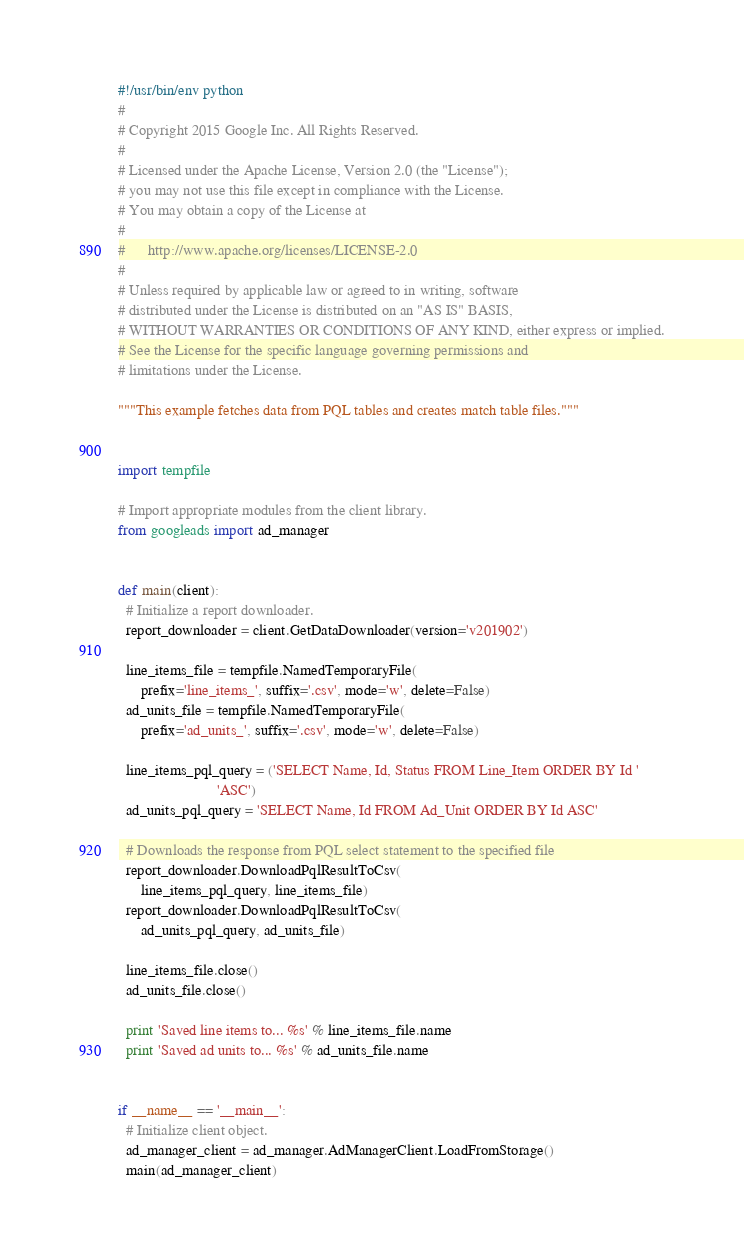<code> <loc_0><loc_0><loc_500><loc_500><_Python_>#!/usr/bin/env python
#
# Copyright 2015 Google Inc. All Rights Reserved.
#
# Licensed under the Apache License, Version 2.0 (the "License");
# you may not use this file except in compliance with the License.
# You may obtain a copy of the License at
#
#      http://www.apache.org/licenses/LICENSE-2.0
#
# Unless required by applicable law or agreed to in writing, software
# distributed under the License is distributed on an "AS IS" BASIS,
# WITHOUT WARRANTIES OR CONDITIONS OF ANY KIND, either express or implied.
# See the License for the specific language governing permissions and
# limitations under the License.

"""This example fetches data from PQL tables and creates match table files."""


import tempfile

# Import appropriate modules from the client library.
from googleads import ad_manager


def main(client):
  # Initialize a report downloader.
  report_downloader = client.GetDataDownloader(version='v201902')

  line_items_file = tempfile.NamedTemporaryFile(
      prefix='line_items_', suffix='.csv', mode='w', delete=False)
  ad_units_file = tempfile.NamedTemporaryFile(
      prefix='ad_units_', suffix='.csv', mode='w', delete=False)

  line_items_pql_query = ('SELECT Name, Id, Status FROM Line_Item ORDER BY Id '
                          'ASC')
  ad_units_pql_query = 'SELECT Name, Id FROM Ad_Unit ORDER BY Id ASC'

  # Downloads the response from PQL select statement to the specified file
  report_downloader.DownloadPqlResultToCsv(
      line_items_pql_query, line_items_file)
  report_downloader.DownloadPqlResultToCsv(
      ad_units_pql_query, ad_units_file)

  line_items_file.close()
  ad_units_file.close()

  print 'Saved line items to... %s' % line_items_file.name
  print 'Saved ad units to... %s' % ad_units_file.name


if __name__ == '__main__':
  # Initialize client object.
  ad_manager_client = ad_manager.AdManagerClient.LoadFromStorage()
  main(ad_manager_client)
</code> 